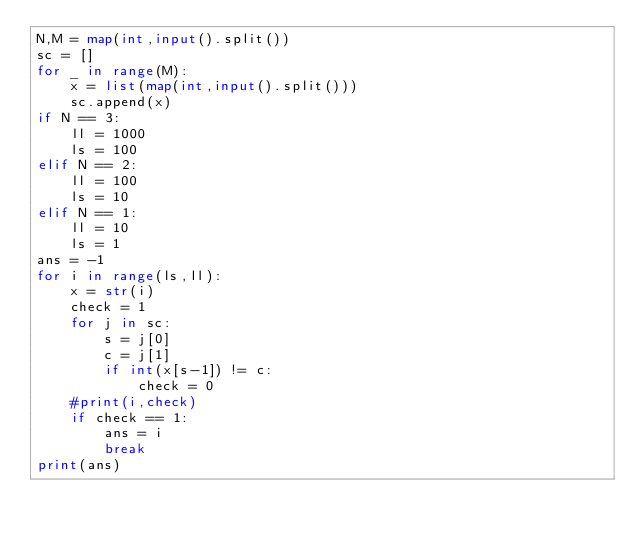Convert code to text. <code><loc_0><loc_0><loc_500><loc_500><_Python_>N,M = map(int,input().split())
sc = []
for _ in range(M):
    x = list(map(int,input().split()))
    sc.append(x)
if N == 3:
    ll = 1000
    ls = 100
elif N == 2:
    ll = 100
    ls = 10
elif N == 1:
    ll = 10
    ls = 1
ans = -1
for i in range(ls,ll):
    x = str(i)
    check = 1
    for j in sc:
        s = j[0]
        c = j[1]
        if int(x[s-1]) != c:
            check = 0
    #print(i,check) 
    if check == 1:
        ans = i
        break
print(ans)</code> 